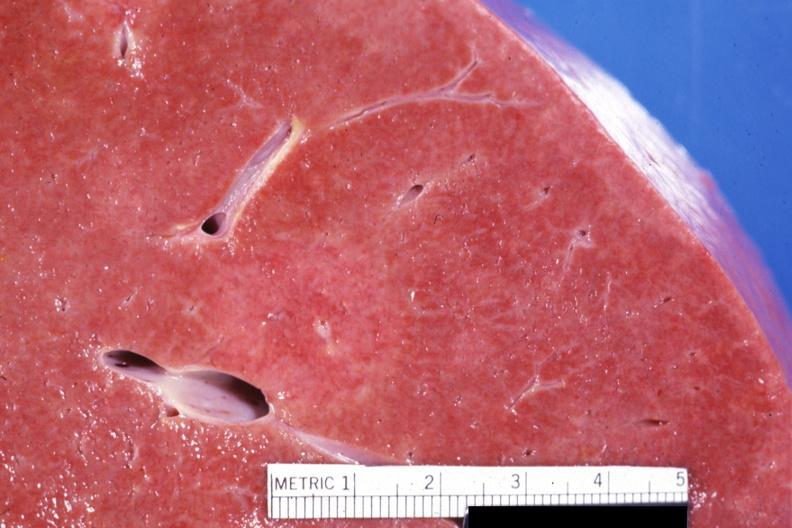s cranial artery present?
Answer the question using a single word or phrase. No 